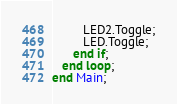<code> <loc_0><loc_0><loc_500><loc_500><_Ada_>         LED2.Toggle;
         LED.Toggle;
      end if;
   end loop;
end Main;
</code> 